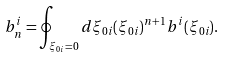Convert formula to latex. <formula><loc_0><loc_0><loc_500><loc_500>b _ { n } ^ { i } = \oint _ { \xi _ { 0 i } = 0 } d \xi _ { 0 i } ( \xi _ { 0 i } ) ^ { n + 1 } b ^ { i } ( \xi _ { 0 i } ) .</formula> 